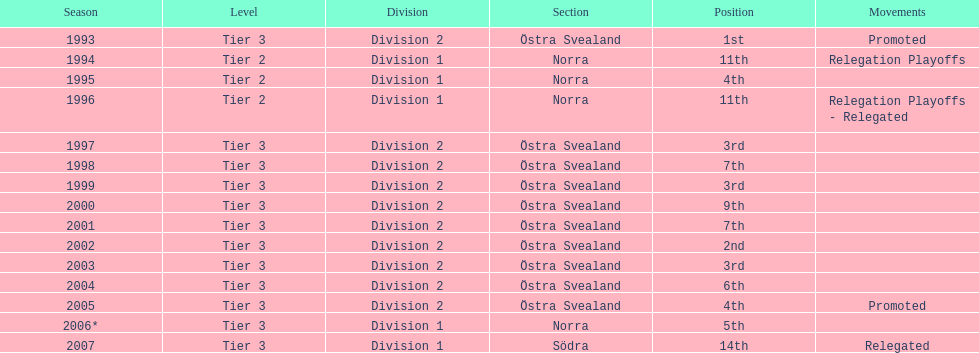In how many instances was norra listed as the section? 4. 